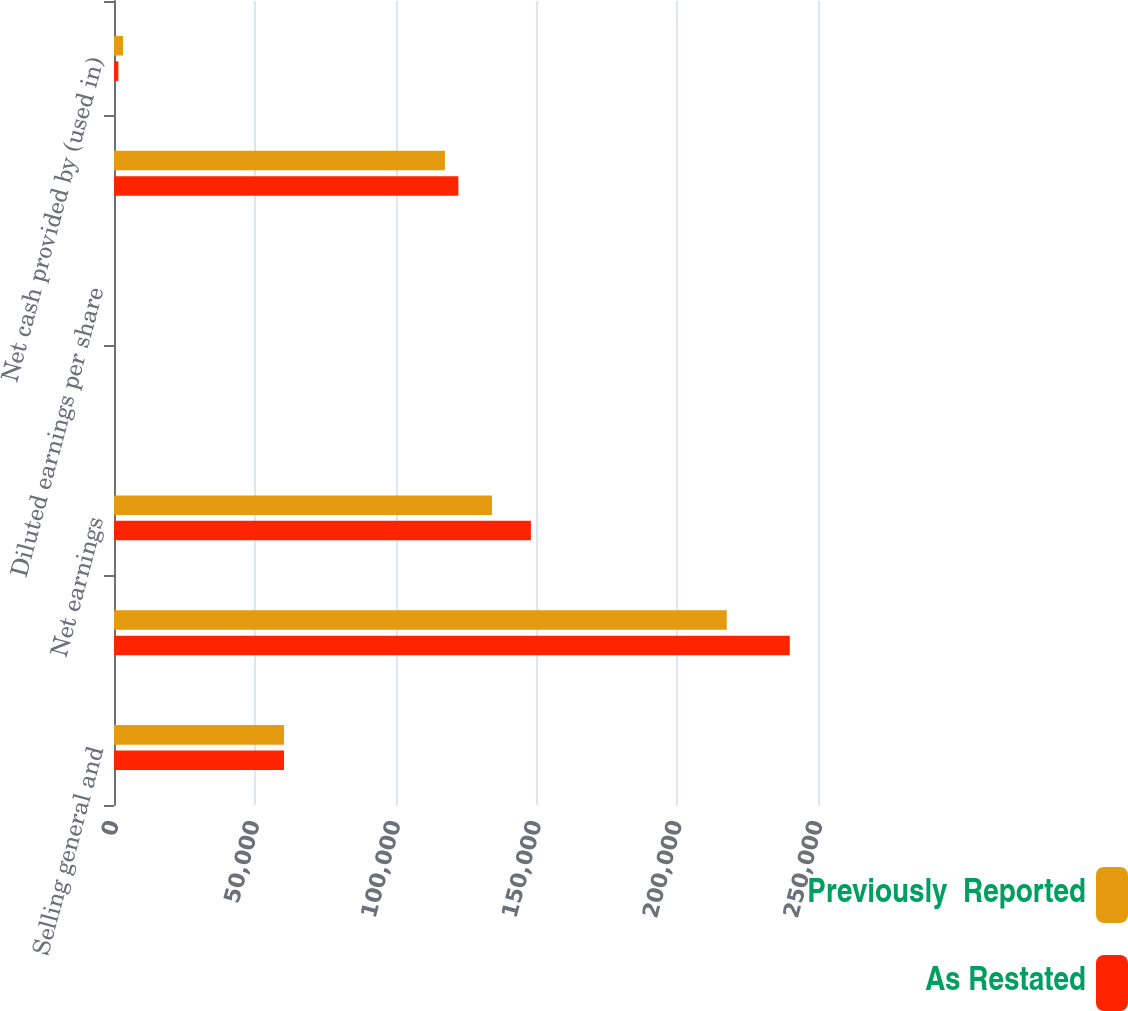Convert chart. <chart><loc_0><loc_0><loc_500><loc_500><stacked_bar_chart><ecel><fcel>Selling general and<fcel>Earnings before income taxes<fcel>Net earnings<fcel>Basic earnings per share<fcel>Diluted earnings per share<fcel>Net cash provided by operating<fcel>Net cash provided by (used in)<nl><fcel>Previously  Reported<fcel>60364<fcel>217601<fcel>134220<fcel>0.64<fcel>0.63<fcel>117513<fcel>3215<nl><fcel>As Restated<fcel>60364<fcel>239983<fcel>148055<fcel>0.71<fcel>0.7<fcel>122295<fcel>1567<nl></chart> 